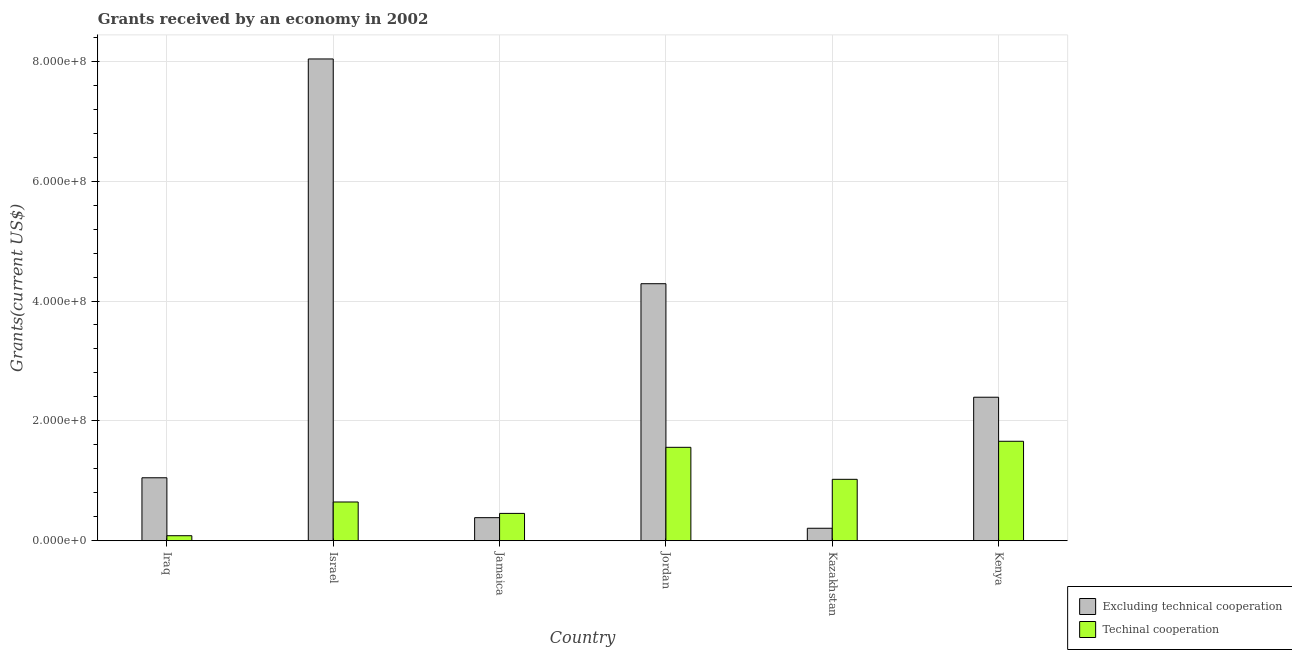How many different coloured bars are there?
Keep it short and to the point. 2. How many groups of bars are there?
Offer a very short reply. 6. What is the label of the 4th group of bars from the left?
Your response must be concise. Jordan. What is the amount of grants received(including technical cooperation) in Kenya?
Give a very brief answer. 1.66e+08. Across all countries, what is the maximum amount of grants received(including technical cooperation)?
Offer a very short reply. 1.66e+08. Across all countries, what is the minimum amount of grants received(excluding technical cooperation)?
Give a very brief answer. 2.08e+07. In which country was the amount of grants received(excluding technical cooperation) minimum?
Give a very brief answer. Kazakhstan. What is the total amount of grants received(including technical cooperation) in the graph?
Give a very brief answer. 5.43e+08. What is the difference between the amount of grants received(including technical cooperation) in Jordan and that in Kenya?
Your answer should be compact. -1.01e+07. What is the difference between the amount of grants received(excluding technical cooperation) in Kenya and the amount of grants received(including technical cooperation) in Jamaica?
Provide a succinct answer. 1.94e+08. What is the average amount of grants received(excluding technical cooperation) per country?
Offer a very short reply. 2.73e+08. What is the difference between the amount of grants received(excluding technical cooperation) and amount of grants received(including technical cooperation) in Jordan?
Provide a succinct answer. 2.73e+08. In how many countries, is the amount of grants received(excluding technical cooperation) greater than 560000000 US$?
Offer a very short reply. 1. What is the ratio of the amount of grants received(including technical cooperation) in Jamaica to that in Kenya?
Give a very brief answer. 0.27. Is the difference between the amount of grants received(excluding technical cooperation) in Jordan and Kenya greater than the difference between the amount of grants received(including technical cooperation) in Jordan and Kenya?
Keep it short and to the point. Yes. What is the difference between the highest and the second highest amount of grants received(including technical cooperation)?
Your answer should be compact. 1.01e+07. What is the difference between the highest and the lowest amount of grants received(excluding technical cooperation)?
Provide a short and direct response. 7.83e+08. What does the 2nd bar from the left in Israel represents?
Provide a succinct answer. Techinal cooperation. What does the 1st bar from the right in Kazakhstan represents?
Provide a succinct answer. Techinal cooperation. How many countries are there in the graph?
Provide a short and direct response. 6. What is the difference between two consecutive major ticks on the Y-axis?
Your answer should be very brief. 2.00e+08. Are the values on the major ticks of Y-axis written in scientific E-notation?
Give a very brief answer. Yes. Does the graph contain grids?
Your answer should be compact. Yes. Where does the legend appear in the graph?
Your answer should be compact. Bottom right. How many legend labels are there?
Provide a short and direct response. 2. What is the title of the graph?
Your answer should be very brief. Grants received by an economy in 2002. Does "Male labourers" appear as one of the legend labels in the graph?
Offer a very short reply. No. What is the label or title of the Y-axis?
Give a very brief answer. Grants(current US$). What is the Grants(current US$) in Excluding technical cooperation in Iraq?
Keep it short and to the point. 1.05e+08. What is the Grants(current US$) in Techinal cooperation in Iraq?
Your answer should be very brief. 8.35e+06. What is the Grants(current US$) in Excluding technical cooperation in Israel?
Give a very brief answer. 8.04e+08. What is the Grants(current US$) of Techinal cooperation in Israel?
Give a very brief answer. 6.46e+07. What is the Grants(current US$) in Excluding technical cooperation in Jamaica?
Your answer should be compact. 3.85e+07. What is the Grants(current US$) in Techinal cooperation in Jamaica?
Make the answer very short. 4.56e+07. What is the Grants(current US$) of Excluding technical cooperation in Jordan?
Keep it short and to the point. 4.29e+08. What is the Grants(current US$) in Techinal cooperation in Jordan?
Make the answer very short. 1.56e+08. What is the Grants(current US$) of Excluding technical cooperation in Kazakhstan?
Your response must be concise. 2.08e+07. What is the Grants(current US$) in Techinal cooperation in Kazakhstan?
Provide a succinct answer. 1.02e+08. What is the Grants(current US$) in Excluding technical cooperation in Kenya?
Provide a short and direct response. 2.39e+08. What is the Grants(current US$) of Techinal cooperation in Kenya?
Offer a very short reply. 1.66e+08. Across all countries, what is the maximum Grants(current US$) in Excluding technical cooperation?
Ensure brevity in your answer.  8.04e+08. Across all countries, what is the maximum Grants(current US$) in Techinal cooperation?
Give a very brief answer. 1.66e+08. Across all countries, what is the minimum Grants(current US$) in Excluding technical cooperation?
Your response must be concise. 2.08e+07. Across all countries, what is the minimum Grants(current US$) of Techinal cooperation?
Offer a terse response. 8.35e+06. What is the total Grants(current US$) of Excluding technical cooperation in the graph?
Ensure brevity in your answer.  1.64e+09. What is the total Grants(current US$) in Techinal cooperation in the graph?
Ensure brevity in your answer.  5.43e+08. What is the difference between the Grants(current US$) of Excluding technical cooperation in Iraq and that in Israel?
Offer a very short reply. -6.99e+08. What is the difference between the Grants(current US$) of Techinal cooperation in Iraq and that in Israel?
Your answer should be compact. -5.63e+07. What is the difference between the Grants(current US$) of Excluding technical cooperation in Iraq and that in Jamaica?
Provide a succinct answer. 6.66e+07. What is the difference between the Grants(current US$) in Techinal cooperation in Iraq and that in Jamaica?
Provide a succinct answer. -3.72e+07. What is the difference between the Grants(current US$) of Excluding technical cooperation in Iraq and that in Jordan?
Provide a short and direct response. -3.24e+08. What is the difference between the Grants(current US$) of Techinal cooperation in Iraq and that in Jordan?
Ensure brevity in your answer.  -1.48e+08. What is the difference between the Grants(current US$) of Excluding technical cooperation in Iraq and that in Kazakhstan?
Give a very brief answer. 8.42e+07. What is the difference between the Grants(current US$) of Techinal cooperation in Iraq and that in Kazakhstan?
Your answer should be very brief. -9.41e+07. What is the difference between the Grants(current US$) of Excluding technical cooperation in Iraq and that in Kenya?
Provide a short and direct response. -1.34e+08. What is the difference between the Grants(current US$) in Techinal cooperation in Iraq and that in Kenya?
Make the answer very short. -1.58e+08. What is the difference between the Grants(current US$) in Excluding technical cooperation in Israel and that in Jamaica?
Make the answer very short. 7.65e+08. What is the difference between the Grants(current US$) in Techinal cooperation in Israel and that in Jamaica?
Offer a very short reply. 1.90e+07. What is the difference between the Grants(current US$) in Excluding technical cooperation in Israel and that in Jordan?
Offer a terse response. 3.75e+08. What is the difference between the Grants(current US$) of Techinal cooperation in Israel and that in Jordan?
Offer a very short reply. -9.12e+07. What is the difference between the Grants(current US$) of Excluding technical cooperation in Israel and that in Kazakhstan?
Ensure brevity in your answer.  7.83e+08. What is the difference between the Grants(current US$) of Techinal cooperation in Israel and that in Kazakhstan?
Provide a succinct answer. -3.78e+07. What is the difference between the Grants(current US$) of Excluding technical cooperation in Israel and that in Kenya?
Your answer should be very brief. 5.64e+08. What is the difference between the Grants(current US$) in Techinal cooperation in Israel and that in Kenya?
Offer a terse response. -1.01e+08. What is the difference between the Grants(current US$) of Excluding technical cooperation in Jamaica and that in Jordan?
Ensure brevity in your answer.  -3.90e+08. What is the difference between the Grants(current US$) of Techinal cooperation in Jamaica and that in Jordan?
Your answer should be very brief. -1.10e+08. What is the difference between the Grants(current US$) of Excluding technical cooperation in Jamaica and that in Kazakhstan?
Make the answer very short. 1.77e+07. What is the difference between the Grants(current US$) in Techinal cooperation in Jamaica and that in Kazakhstan?
Your answer should be compact. -5.69e+07. What is the difference between the Grants(current US$) of Excluding technical cooperation in Jamaica and that in Kenya?
Provide a short and direct response. -2.01e+08. What is the difference between the Grants(current US$) in Techinal cooperation in Jamaica and that in Kenya?
Offer a very short reply. -1.20e+08. What is the difference between the Grants(current US$) in Excluding technical cooperation in Jordan and that in Kazakhstan?
Provide a short and direct response. 4.08e+08. What is the difference between the Grants(current US$) of Techinal cooperation in Jordan and that in Kazakhstan?
Make the answer very short. 5.34e+07. What is the difference between the Grants(current US$) in Excluding technical cooperation in Jordan and that in Kenya?
Provide a short and direct response. 1.89e+08. What is the difference between the Grants(current US$) of Techinal cooperation in Jordan and that in Kenya?
Keep it short and to the point. -1.01e+07. What is the difference between the Grants(current US$) in Excluding technical cooperation in Kazakhstan and that in Kenya?
Provide a short and direct response. -2.19e+08. What is the difference between the Grants(current US$) in Techinal cooperation in Kazakhstan and that in Kenya?
Offer a terse response. -6.35e+07. What is the difference between the Grants(current US$) of Excluding technical cooperation in Iraq and the Grants(current US$) of Techinal cooperation in Israel?
Your response must be concise. 4.04e+07. What is the difference between the Grants(current US$) in Excluding technical cooperation in Iraq and the Grants(current US$) in Techinal cooperation in Jamaica?
Your answer should be very brief. 5.94e+07. What is the difference between the Grants(current US$) of Excluding technical cooperation in Iraq and the Grants(current US$) of Techinal cooperation in Jordan?
Provide a short and direct response. -5.08e+07. What is the difference between the Grants(current US$) of Excluding technical cooperation in Iraq and the Grants(current US$) of Techinal cooperation in Kazakhstan?
Your response must be concise. 2.58e+06. What is the difference between the Grants(current US$) of Excluding technical cooperation in Iraq and the Grants(current US$) of Techinal cooperation in Kenya?
Your answer should be compact. -6.09e+07. What is the difference between the Grants(current US$) of Excluding technical cooperation in Israel and the Grants(current US$) of Techinal cooperation in Jamaica?
Offer a terse response. 7.58e+08. What is the difference between the Grants(current US$) of Excluding technical cooperation in Israel and the Grants(current US$) of Techinal cooperation in Jordan?
Provide a succinct answer. 6.48e+08. What is the difference between the Grants(current US$) of Excluding technical cooperation in Israel and the Grants(current US$) of Techinal cooperation in Kazakhstan?
Make the answer very short. 7.01e+08. What is the difference between the Grants(current US$) in Excluding technical cooperation in Israel and the Grants(current US$) in Techinal cooperation in Kenya?
Your answer should be compact. 6.38e+08. What is the difference between the Grants(current US$) of Excluding technical cooperation in Jamaica and the Grants(current US$) of Techinal cooperation in Jordan?
Your response must be concise. -1.17e+08. What is the difference between the Grants(current US$) of Excluding technical cooperation in Jamaica and the Grants(current US$) of Techinal cooperation in Kazakhstan?
Give a very brief answer. -6.40e+07. What is the difference between the Grants(current US$) of Excluding technical cooperation in Jamaica and the Grants(current US$) of Techinal cooperation in Kenya?
Provide a short and direct response. -1.27e+08. What is the difference between the Grants(current US$) of Excluding technical cooperation in Jordan and the Grants(current US$) of Techinal cooperation in Kazakhstan?
Your answer should be very brief. 3.26e+08. What is the difference between the Grants(current US$) in Excluding technical cooperation in Jordan and the Grants(current US$) in Techinal cooperation in Kenya?
Ensure brevity in your answer.  2.63e+08. What is the difference between the Grants(current US$) in Excluding technical cooperation in Kazakhstan and the Grants(current US$) in Techinal cooperation in Kenya?
Make the answer very short. -1.45e+08. What is the average Grants(current US$) in Excluding technical cooperation per country?
Make the answer very short. 2.73e+08. What is the average Grants(current US$) in Techinal cooperation per country?
Your answer should be compact. 9.05e+07. What is the difference between the Grants(current US$) of Excluding technical cooperation and Grants(current US$) of Techinal cooperation in Iraq?
Give a very brief answer. 9.67e+07. What is the difference between the Grants(current US$) in Excluding technical cooperation and Grants(current US$) in Techinal cooperation in Israel?
Ensure brevity in your answer.  7.39e+08. What is the difference between the Grants(current US$) in Excluding technical cooperation and Grants(current US$) in Techinal cooperation in Jamaica?
Provide a short and direct response. -7.11e+06. What is the difference between the Grants(current US$) in Excluding technical cooperation and Grants(current US$) in Techinal cooperation in Jordan?
Your answer should be compact. 2.73e+08. What is the difference between the Grants(current US$) of Excluding technical cooperation and Grants(current US$) of Techinal cooperation in Kazakhstan?
Give a very brief answer. -8.16e+07. What is the difference between the Grants(current US$) in Excluding technical cooperation and Grants(current US$) in Techinal cooperation in Kenya?
Ensure brevity in your answer.  7.35e+07. What is the ratio of the Grants(current US$) of Excluding technical cooperation in Iraq to that in Israel?
Provide a short and direct response. 0.13. What is the ratio of the Grants(current US$) in Techinal cooperation in Iraq to that in Israel?
Ensure brevity in your answer.  0.13. What is the ratio of the Grants(current US$) in Excluding technical cooperation in Iraq to that in Jamaica?
Your answer should be very brief. 2.73. What is the ratio of the Grants(current US$) of Techinal cooperation in Iraq to that in Jamaica?
Offer a terse response. 0.18. What is the ratio of the Grants(current US$) in Excluding technical cooperation in Iraq to that in Jordan?
Your response must be concise. 0.24. What is the ratio of the Grants(current US$) in Techinal cooperation in Iraq to that in Jordan?
Ensure brevity in your answer.  0.05. What is the ratio of the Grants(current US$) of Excluding technical cooperation in Iraq to that in Kazakhstan?
Your answer should be compact. 5.05. What is the ratio of the Grants(current US$) in Techinal cooperation in Iraq to that in Kazakhstan?
Your answer should be very brief. 0.08. What is the ratio of the Grants(current US$) of Excluding technical cooperation in Iraq to that in Kenya?
Your answer should be compact. 0.44. What is the ratio of the Grants(current US$) in Techinal cooperation in Iraq to that in Kenya?
Ensure brevity in your answer.  0.05. What is the ratio of the Grants(current US$) of Excluding technical cooperation in Israel to that in Jamaica?
Offer a very short reply. 20.89. What is the ratio of the Grants(current US$) of Techinal cooperation in Israel to that in Jamaica?
Your response must be concise. 1.42. What is the ratio of the Grants(current US$) in Excluding technical cooperation in Israel to that in Jordan?
Ensure brevity in your answer.  1.87. What is the ratio of the Grants(current US$) in Techinal cooperation in Israel to that in Jordan?
Make the answer very short. 0.41. What is the ratio of the Grants(current US$) of Excluding technical cooperation in Israel to that in Kazakhstan?
Your answer should be very brief. 38.65. What is the ratio of the Grants(current US$) of Techinal cooperation in Israel to that in Kazakhstan?
Keep it short and to the point. 0.63. What is the ratio of the Grants(current US$) in Excluding technical cooperation in Israel to that in Kenya?
Make the answer very short. 3.36. What is the ratio of the Grants(current US$) in Techinal cooperation in Israel to that in Kenya?
Your answer should be very brief. 0.39. What is the ratio of the Grants(current US$) of Excluding technical cooperation in Jamaica to that in Jordan?
Your answer should be compact. 0.09. What is the ratio of the Grants(current US$) in Techinal cooperation in Jamaica to that in Jordan?
Your answer should be very brief. 0.29. What is the ratio of the Grants(current US$) in Excluding technical cooperation in Jamaica to that in Kazakhstan?
Offer a very short reply. 1.85. What is the ratio of the Grants(current US$) in Techinal cooperation in Jamaica to that in Kazakhstan?
Ensure brevity in your answer.  0.45. What is the ratio of the Grants(current US$) of Excluding technical cooperation in Jamaica to that in Kenya?
Provide a short and direct response. 0.16. What is the ratio of the Grants(current US$) in Techinal cooperation in Jamaica to that in Kenya?
Your answer should be very brief. 0.27. What is the ratio of the Grants(current US$) in Excluding technical cooperation in Jordan to that in Kazakhstan?
Provide a short and direct response. 20.62. What is the ratio of the Grants(current US$) in Techinal cooperation in Jordan to that in Kazakhstan?
Your response must be concise. 1.52. What is the ratio of the Grants(current US$) in Excluding technical cooperation in Jordan to that in Kenya?
Keep it short and to the point. 1.79. What is the ratio of the Grants(current US$) of Techinal cooperation in Jordan to that in Kenya?
Your response must be concise. 0.94. What is the ratio of the Grants(current US$) of Excluding technical cooperation in Kazakhstan to that in Kenya?
Your answer should be compact. 0.09. What is the ratio of the Grants(current US$) in Techinal cooperation in Kazakhstan to that in Kenya?
Your response must be concise. 0.62. What is the difference between the highest and the second highest Grants(current US$) in Excluding technical cooperation?
Keep it short and to the point. 3.75e+08. What is the difference between the highest and the second highest Grants(current US$) of Techinal cooperation?
Your answer should be very brief. 1.01e+07. What is the difference between the highest and the lowest Grants(current US$) of Excluding technical cooperation?
Your response must be concise. 7.83e+08. What is the difference between the highest and the lowest Grants(current US$) of Techinal cooperation?
Give a very brief answer. 1.58e+08. 